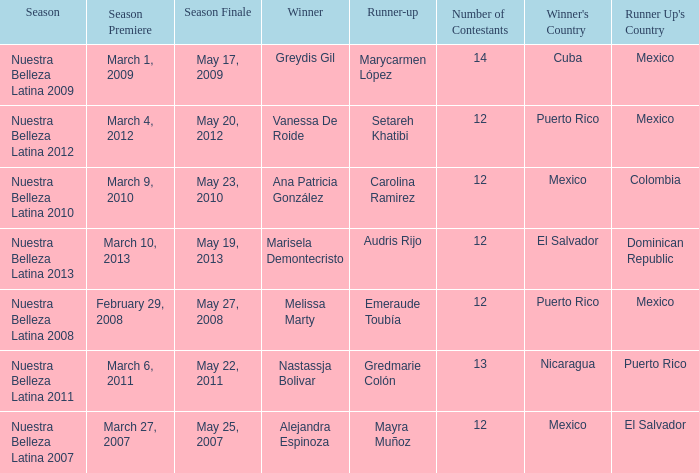How many contestants were there in a season where alejandra espinoza won? 1.0. 